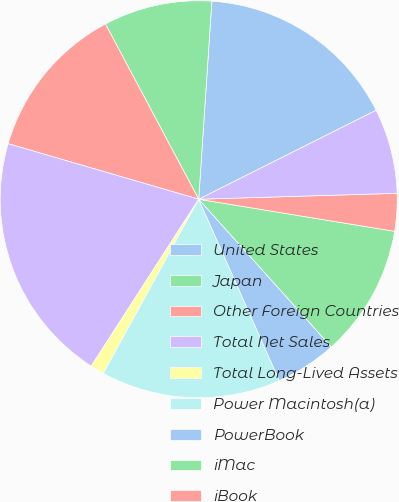Convert chart to OTSL. <chart><loc_0><loc_0><loc_500><loc_500><pie_chart><fcel>United States<fcel>Japan<fcel>Other Foreign Countries<fcel>Total Net Sales<fcel>Total Long-Lived Assets<fcel>Power Macintosh(a)<fcel>PowerBook<fcel>iMac<fcel>iBook<fcel>Software Service and Other Net<nl><fcel>16.55%<fcel>8.84%<fcel>12.7%<fcel>20.41%<fcel>1.13%<fcel>14.63%<fcel>4.99%<fcel>10.77%<fcel>3.06%<fcel>6.92%<nl></chart> 